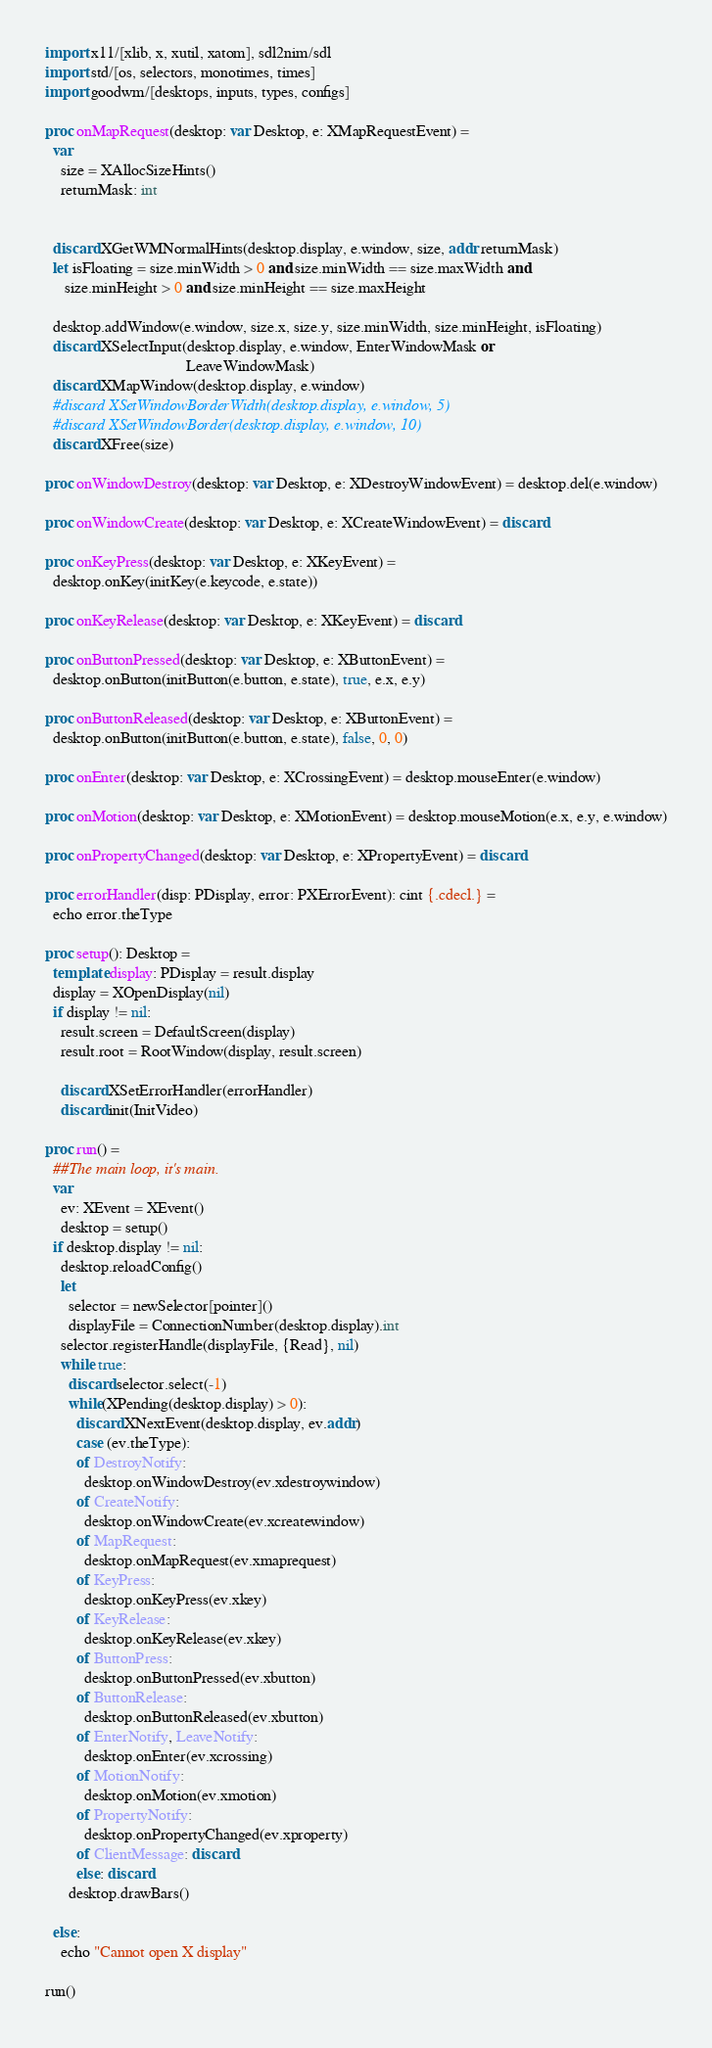Convert code to text. <code><loc_0><loc_0><loc_500><loc_500><_Nim_>import x11/[xlib, x, xutil, xatom], sdl2nim/sdl
import std/[os, selectors, monotimes, times]
import goodwm/[desktops, inputs, types, configs]

proc onMapRequest(desktop: var Desktop, e: XMapRequestEvent) =
  var
    size = XAllocSizeHints()
    returnMask: int


  discard XGetWMNormalHints(desktop.display, e.window, size, addr returnMask)
  let isFloating = size.minWidth > 0 and size.minWidth == size.maxWidth and
     size.minHeight > 0 and size.minHeight == size.maxHeight

  desktop.addWindow(e.window, size.x, size.y, size.minWidth, size.minHeight, isFloating)
  discard XSelectInput(desktop.display, e.window, EnterWindowMask or
                                    LeaveWindowMask)
  discard XMapWindow(desktop.display, e.window)
  #discard XSetWindowBorderWidth(desktop.display, e.window, 5)
  #discard XSetWindowBorder(desktop.display, e.window, 10)
  discard XFree(size)

proc onWindowDestroy(desktop: var Desktop, e: XDestroyWindowEvent) = desktop.del(e.window)

proc onWindowCreate(desktop: var Desktop, e: XCreateWindowEvent) = discard

proc onKeyPress(desktop: var Desktop, e: XKeyEvent) =
  desktop.onKey(initKey(e.keycode, e.state))

proc onKeyRelease(desktop: var Desktop, e: XKeyEvent) = discard

proc onButtonPressed(desktop: var Desktop, e: XButtonEvent) =
  desktop.onButton(initButton(e.button, e.state), true, e.x, e.y)

proc onButtonReleased(desktop: var Desktop, e: XButtonEvent) =
  desktop.onButton(initButton(e.button, e.state), false, 0, 0)

proc onEnter(desktop: var Desktop, e: XCrossingEvent) = desktop.mouseEnter(e.window)

proc onMotion(desktop: var Desktop, e: XMotionEvent) = desktop.mouseMotion(e.x, e.y, e.window)

proc onPropertyChanged(desktop: var Desktop, e: XPropertyEvent) = discard

proc errorHandler(disp: PDisplay, error: PXErrorEvent): cint {.cdecl.} =
  echo error.theType

proc setup(): Desktop =
  template display: PDisplay = result.display
  display = XOpenDisplay(nil)
  if display != nil:
    result.screen = DefaultScreen(display)
    result.root = RootWindow(display, result.screen)

    discard XSetErrorHandler(errorHandler)
    discard init(InitVideo)

proc run() =
  ##The main loop, it's main.
  var
    ev: XEvent = XEvent()
    desktop = setup()
  if desktop.display != nil:
    desktop.reloadConfig()
    let
      selector = newSelector[pointer]()
      displayFile = ConnectionNumber(desktop.display).int
    selector.registerHandle(displayFile, {Read}, nil)
    while true:
      discard selector.select(-1)
      while(XPending(desktop.display) > 0):
        discard XNextEvent(desktop.display, ev.addr)
        case (ev.theType):
        of DestroyNotify:
          desktop.onWindowDestroy(ev.xdestroywindow)
        of CreateNotify:
          desktop.onWindowCreate(ev.xcreatewindow)
        of MapRequest:
          desktop.onMapRequest(ev.xmaprequest)
        of KeyPress:
          desktop.onKeyPress(ev.xkey)
        of KeyRelease:
          desktop.onKeyRelease(ev.xkey)
        of ButtonPress:
          desktop.onButtonPressed(ev.xbutton)
        of ButtonRelease:
          desktop.onButtonReleased(ev.xbutton)
        of EnterNotify, LeaveNotify:
          desktop.onEnter(ev.xcrossing)
        of MotionNotify:
          desktop.onMotion(ev.xmotion)
        of PropertyNotify:
          desktop.onPropertyChanged(ev.xproperty)
        of ClientMessage: discard
        else: discard
      desktop.drawBars()

  else:
    echo "Cannot open X display"

run()
</code> 